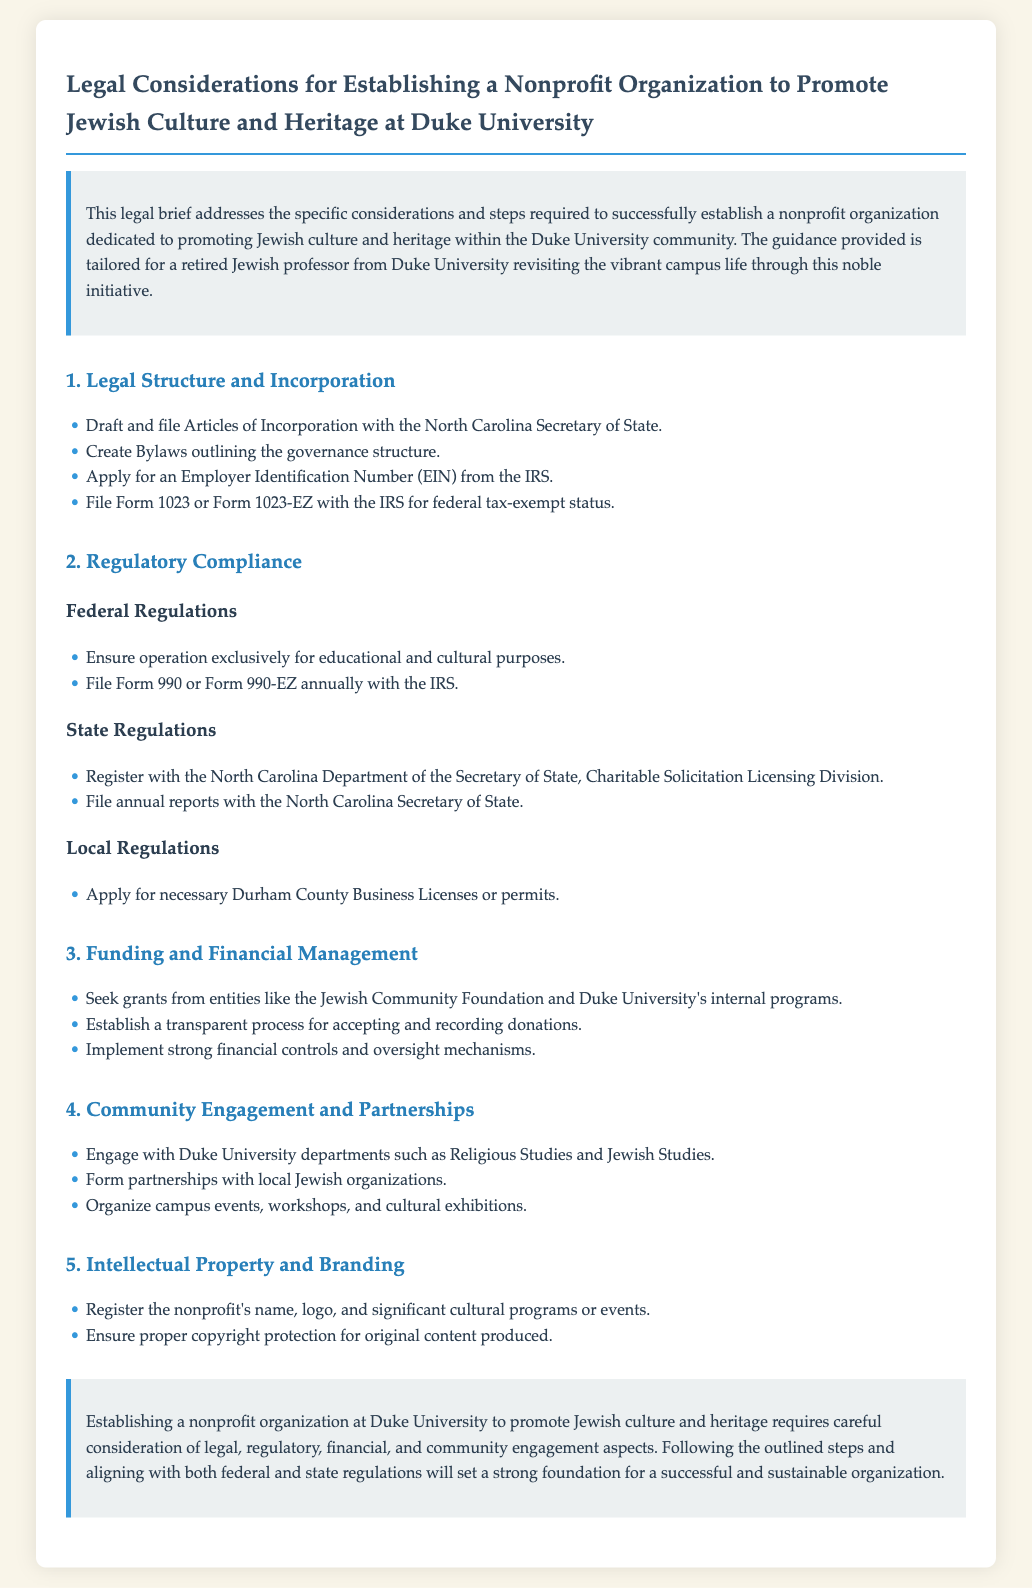What are the Articles of Incorporation? The Articles of Incorporation need to be drafted and filed with the North Carolina Secretary of State to legally establish the nonprofit.
Answer: Articles of Incorporation What form is used to apply for federal tax-exempt status? Form 1023 or Form 1023-EZ must be filed with the IRS to apply for federal tax-exempt status.
Answer: Form 1023 or Form 1023-EZ Which department in North Carolina requires registration for charitable solicitations? The North Carolina Department of the Secretary of State, Charitable Solicitation Licensing Division requires registration.
Answer: Charitable Solicitation Licensing Division What must the nonprofit ensure regarding its operation? The nonprofit must operate exclusively for educational and cultural purposes to comply with federal regulations.
Answer: Educational and cultural purposes Which university departments should be engaged for community outreach? Engaging with Duke University departments such as Religious Studies and Jewish Studies is recommended for community outreach.
Answer: Religious Studies and Jewish Studies What type of oversight is necessary for financial management? Strong financial controls and oversight mechanisms should be implemented for managing finances of the nonprofit.
Answer: Financial controls What should be done to protect original content? Copyright protection must be ensured for original content produced by the nonprofit.
Answer: Copyright protection Which two organizations could provide funding through grants? Grants could be sought from the Jewish Community Foundation and Duke University's internal programs.
Answer: Jewish Community Foundation and Duke University's internal programs 